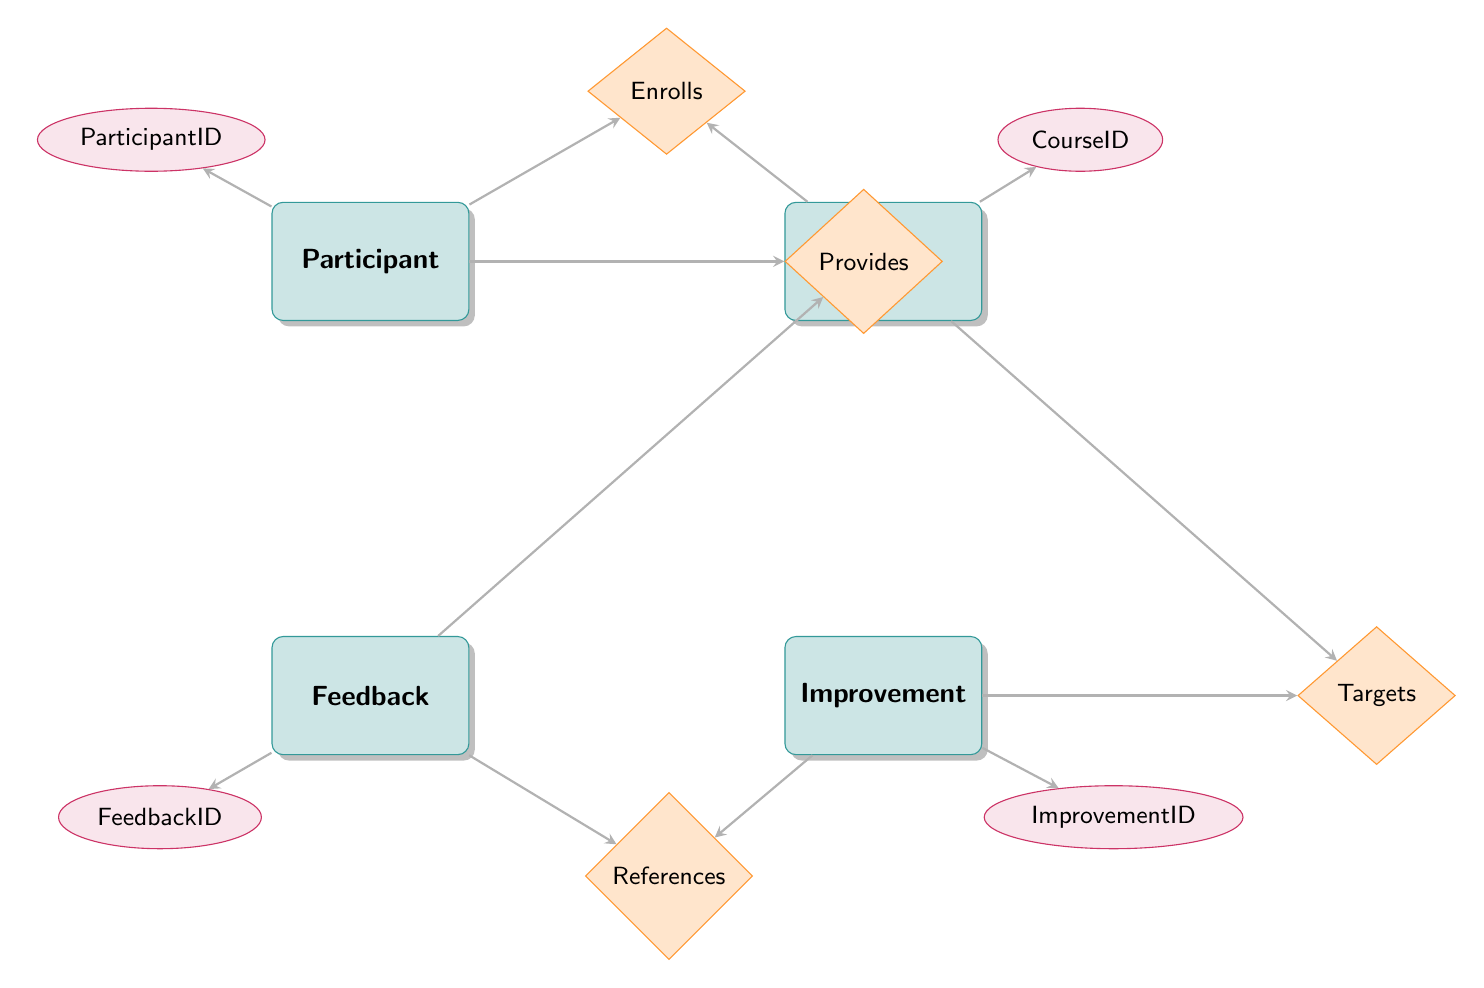What are the main entities in the diagram? The diagram shows four main entities: Participant, Course, Feedback, and Improvement. These are the largest nodes that represent the key components of the system.
Answer: Participant, Course, Feedback, Improvement How many relationships are there between entities? There are four relationships identifiable in the diagram: Enrolls, Provides, Targets, and References. Each relationship connects different entities, indicating interactions.
Answer: 4 What does the 'Enrolls' relationship connect? The 'Enrolls' relationship connects the Participant and Course entities, indicating that participants enroll in courses. This is represented by the line connecting the two entities through the diamond shape of the relationship.
Answer: Participant and Course What is the purpose of the 'References' relationship? The 'References' relationship connects Feedback and Improvement entities, indicating that feedback can reference specific suggestions for improvement. This establishes a link that suggests improvements may come from participants' feedback.
Answer: Feedback and Improvement Which entity has an attribute named 'ParticipantID'? The entity that contains the 'ParticipantID' attribute is the Participant. This unique identifier is crucial for distinguishing between different participants in the educational program.
Answer: Participant 